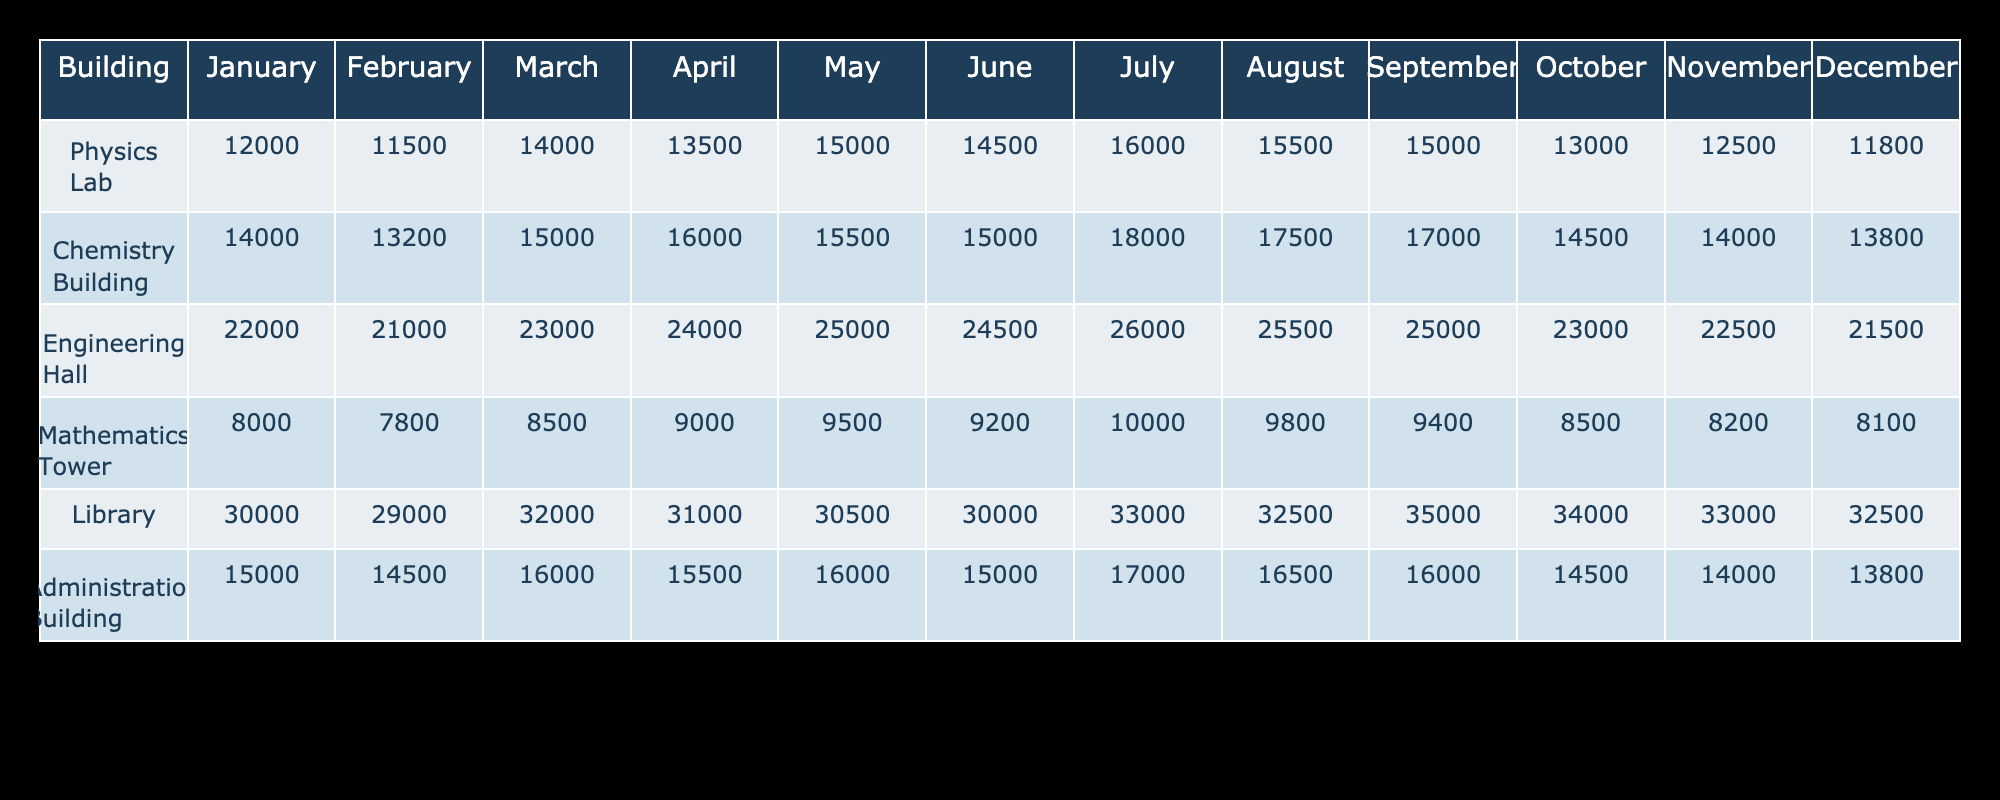What is the energy consumption of the Physics Lab in April? The energy consumption of the Physics Lab is directly listed in the April column of the table. It shows the value 13500.
Answer: 13500 Which building has the highest energy consumption in January? By checking the January values for each building, we see the Library has the highest energy consumption of 30000.
Answer: Library What is the total energy consumption for the Chemistry Building over the year? Add all monthly values for the Chemistry Building: 14000 + 13200 + 15000 + 16000 + 15500 + 15000 + 18000 + 17500 + 17000 + 14500 + 14000 + 13800 = 183200.
Answer: 183200 Is the energy consumption of Engineering Hall lower in November than in October? The Engineering Hall consumption in November is 22500 while in October it's 23000. Since 22500 is less than 23000, the answer is yes.
Answer: Yes Which month has the highest overall energy consumption across all buildings? To find this, sum each building's monthly consumption for each month and compare the totals. For example, January totals to 12000 + 14000 + 22000 + 8000 + 30000 + 15000 = 101000. Doing this for all months, August has the highest total, which is 92000.
Answer: August What is the average energy consumption in July for all buildings? The July values are: 16000, 18000, 26000, 10000, 33000, 17000. Adding these gives a total of 116000, then divide by the number of buildings, which is 6: 116000 / 6 = 19333.33.
Answer: 19333.33 Did the energy consumption of the Library ever drop below 30000 throughout the year? Checking the Library's monthly values, they all exceed 30000, confirming that the consumption never dropped below this threshold.
Answer: No How does the average energy consumption of the Mathematics Tower compare to that of the Administration Building? Calculating the average for the Mathematics Tower: (8000 + 7800 + 8500 + 9000 + 9500 + 9200 + 10000 + 9800 + 9400 + 8500 + 8200 + 8100) = 8775; Administration: (15000 + 14500 + 16000 + 15500 + 16000 + 15000 + 17000 + 16500 + 16000 + 14500 + 14000 + 13800) = 15392.50. The Administration Building has a higher average.
Answer: Administration Building Which month had the largest increase in energy consumption for the Engineering Hall? By examining the monthly values for the Engineering Hall, the most significant increase occurs from March to April (from 23000 to 24000), which is an increase of 1000.
Answer: April 